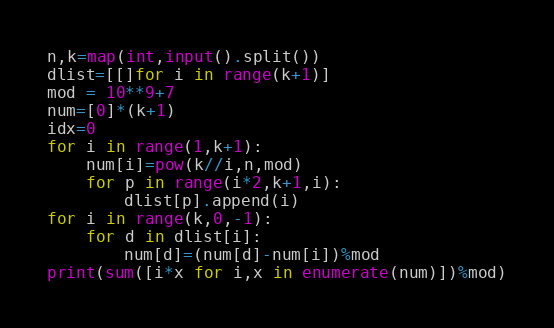Convert code to text. <code><loc_0><loc_0><loc_500><loc_500><_Python_>n,k=map(int,input().split())
dlist=[[]for i in range(k+1)]
mod = 10**9+7
num=[0]*(k+1)
idx=0
for i in range(1,k+1):
    num[i]=pow(k//i,n,mod)
    for p in range(i*2,k+1,i):
        dlist[p].append(i)
for i in range(k,0,-1):
    for d in dlist[i]:
        num[d]=(num[d]-num[i])%mod
print(sum([i*x for i,x in enumerate(num)])%mod)</code> 